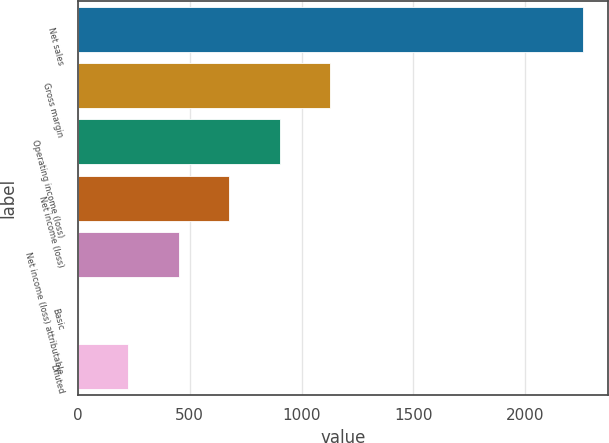<chart> <loc_0><loc_0><loc_500><loc_500><bar_chart><fcel>Net sales<fcel>Gross margin<fcel>Operating income (loss)<fcel>Net income (loss)<fcel>Net income (loss) attributable<fcel>Basic<fcel>Diluted<nl><fcel>2257<fcel>1128.52<fcel>902.83<fcel>677.14<fcel>451.45<fcel>0.07<fcel>225.76<nl></chart> 